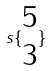Convert formula to latex. <formula><loc_0><loc_0><loc_500><loc_500>s \{ \begin{matrix} 5 \\ 3 \end{matrix} \}</formula> 